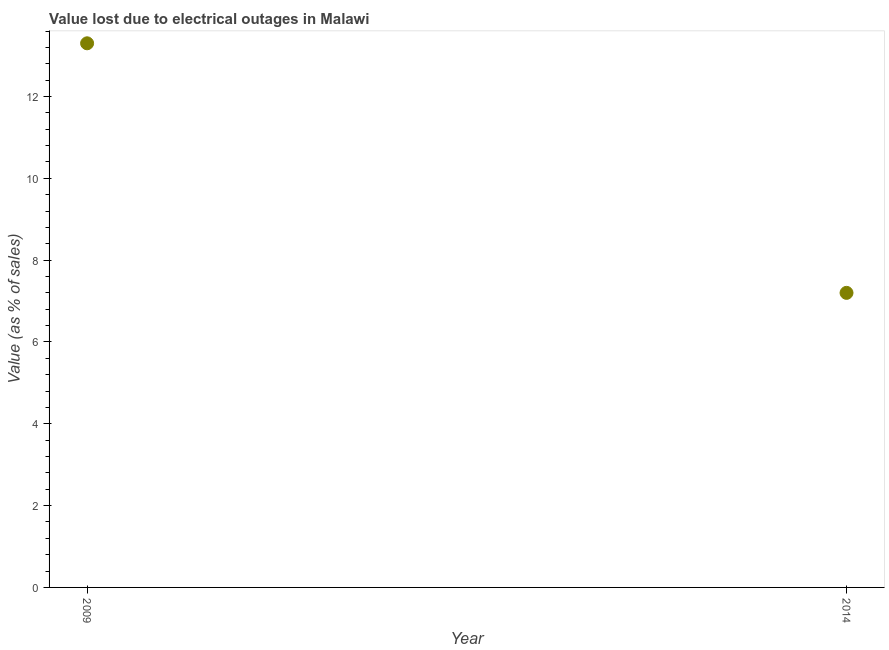What is the value lost due to electrical outages in 2014?
Give a very brief answer. 7.2. In which year was the value lost due to electrical outages minimum?
Provide a short and direct response. 2014. What is the difference between the value lost due to electrical outages in 2009 and 2014?
Offer a terse response. 6.1. What is the average value lost due to electrical outages per year?
Give a very brief answer. 10.25. What is the median value lost due to electrical outages?
Your response must be concise. 10.25. In how many years, is the value lost due to electrical outages greater than 9.6 %?
Make the answer very short. 1. Do a majority of the years between 2009 and 2014 (inclusive) have value lost due to electrical outages greater than 12.4 %?
Offer a very short reply. No. What is the ratio of the value lost due to electrical outages in 2009 to that in 2014?
Provide a succinct answer. 1.85. In how many years, is the value lost due to electrical outages greater than the average value lost due to electrical outages taken over all years?
Give a very brief answer. 1. Does the value lost due to electrical outages monotonically increase over the years?
Your answer should be very brief. No. How many dotlines are there?
Ensure brevity in your answer.  1. How many years are there in the graph?
Offer a terse response. 2. What is the difference between two consecutive major ticks on the Y-axis?
Make the answer very short. 2. Does the graph contain any zero values?
Ensure brevity in your answer.  No. Does the graph contain grids?
Give a very brief answer. No. What is the title of the graph?
Make the answer very short. Value lost due to electrical outages in Malawi. What is the label or title of the X-axis?
Offer a terse response. Year. What is the label or title of the Y-axis?
Ensure brevity in your answer.  Value (as % of sales). What is the Value (as % of sales) in 2009?
Your answer should be compact. 13.3. What is the Value (as % of sales) in 2014?
Offer a terse response. 7.2. What is the ratio of the Value (as % of sales) in 2009 to that in 2014?
Your answer should be compact. 1.85. 